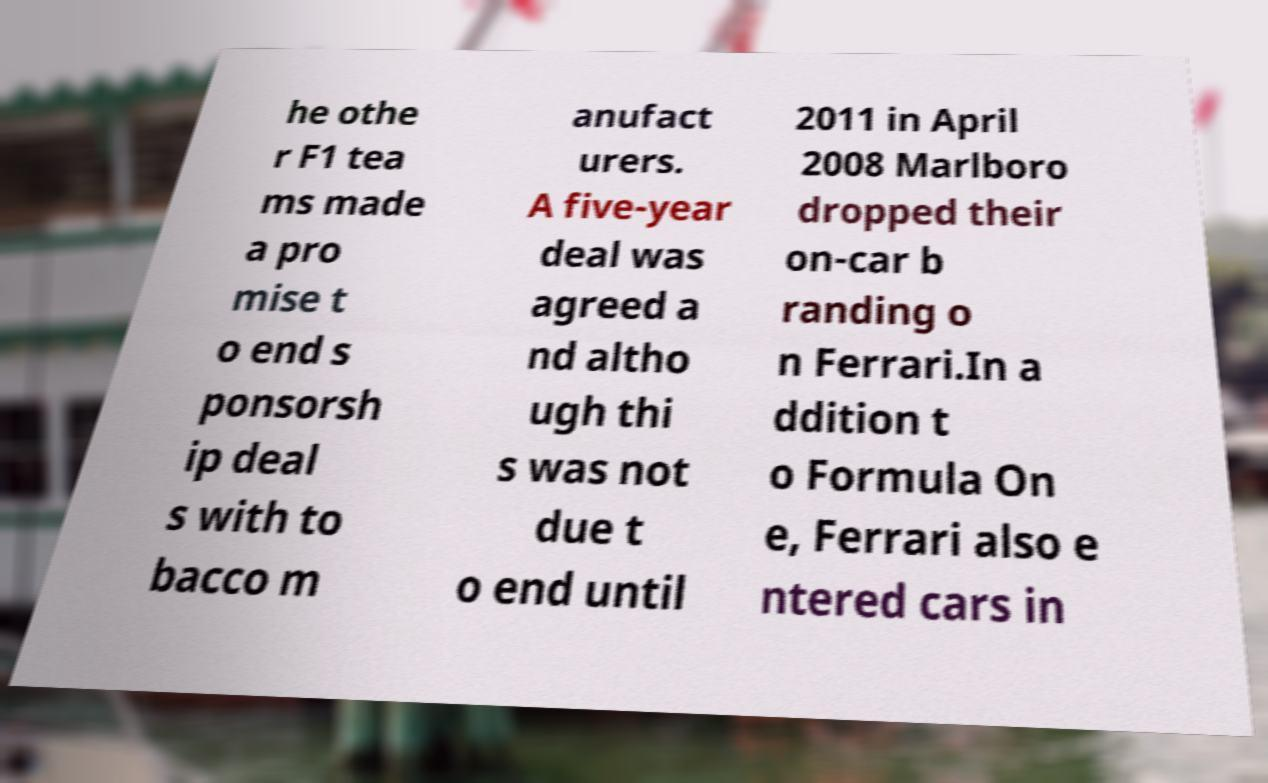What messages or text are displayed in this image? I need them in a readable, typed format. he othe r F1 tea ms made a pro mise t o end s ponsorsh ip deal s with to bacco m anufact urers. A five-year deal was agreed a nd altho ugh thi s was not due t o end until 2011 in April 2008 Marlboro dropped their on-car b randing o n Ferrari.In a ddition t o Formula On e, Ferrari also e ntered cars in 